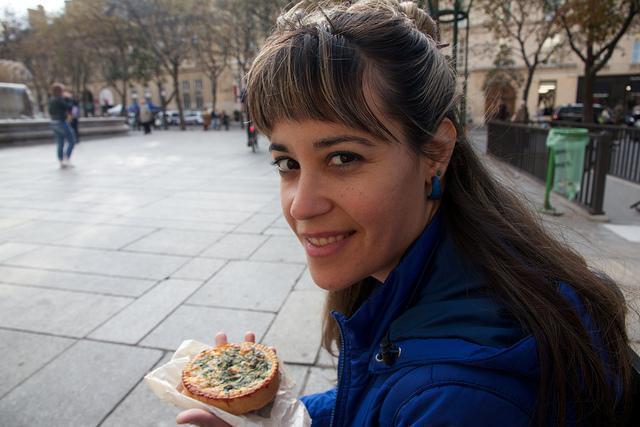What material are the earrings made of?
Make your selection and explain in format: 'Answer: answer
Rationale: rationale.'
Options: Crystal, jade, metal, plastic. Answer: metal.
Rationale: They appear to be metallic in design and that is common for earrings. What is matching the color of her jacket?
Indicate the correct choice and explain in the format: 'Answer: answer
Rationale: rationale.'
Options: Hair, eyebrows, earrings, lipstick. Answer: earrings.
Rationale: The earrings are a bright blue. 